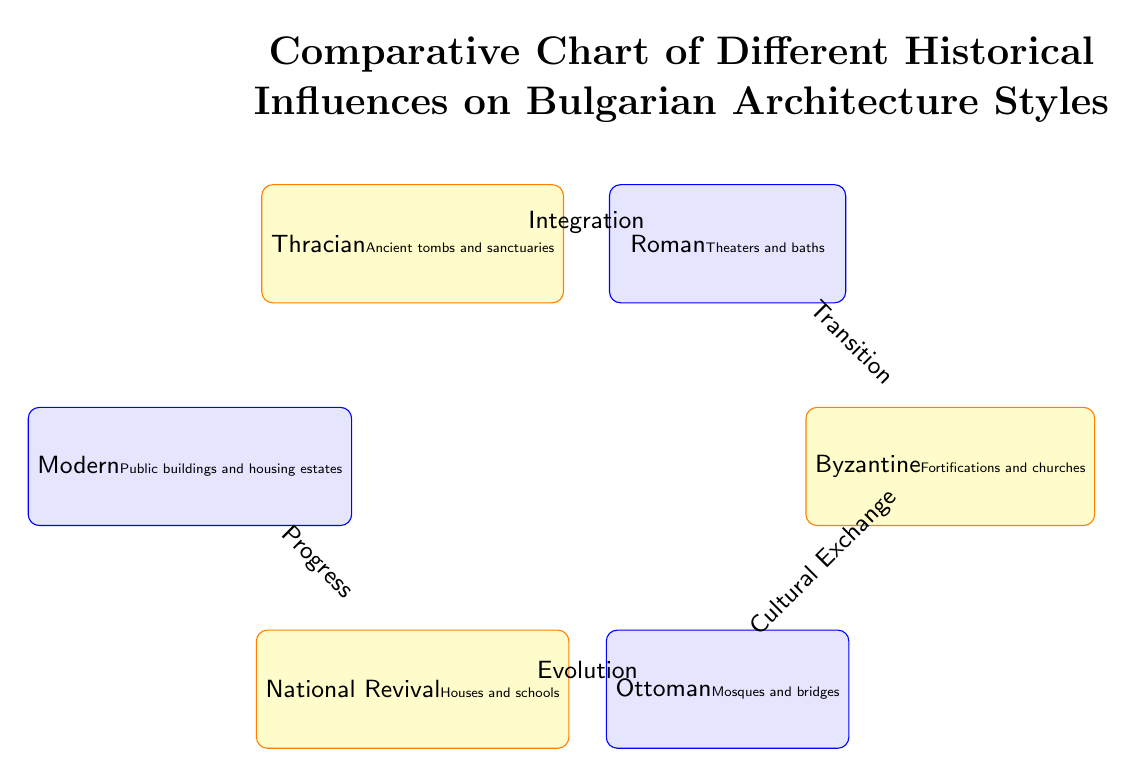What is the first historical influence depicted in the chart? The first node in the diagram is labeled "Thracian," indicating it is the first historical influence presented.
Answer: Thracian Which architecture style is associated with mosques and bridges? The node that contains "Mosques and bridges" is labeled as "Ottoman," indicating this architecture style is associated with that description.
Answer: Ottoman What relationship connects the Thracian and Roman influences? The diagram illustrates an arrow labeled "Integration" connecting the "Thracian" node and the "Roman" node, indicating the nature of the relationship between these two influences.
Answer: Integration Which style follows the Byzantine influence in the chart? Following the "Byzantine" node, the next node down in the chart is "Ottoman," indicating it is the style that comes after Byzantine.
Answer: Ottoman How many total architecture styles are represented in the chart? By counting the nodes in the diagram, there are six distinct styles displayed, which include Thracian, Roman, Byzantine, Ottoman, National Revival, and Modern.
Answer: 6 What type of building is associated with the National Revival style? The National Revival node explicitly mentions "Houses and schools," indicating these types of buildings are aligned with this architectural style.
Answer: Houses and schools What is the flow direction from the Modern style to previous styles? The arrow from "Modern" style points upwards back to "National Revival," indicating a progression from Modern architecture to the earlier styles presented in the chart.
Answer: Progress Which two styles are connected by the term "Cultural Exchange"? The "Cultural Exchange" relationship directly connects the "Byzantine" style to the "Ottoman" style, indicating this specific interaction.
Answer: Byzantine and Ottoman Which architecture style is placed at the top of the chart? The chart does not have any nodes above; however, "Modern" is the highest style in this visual representation based on the directed arrows indicating progressions.
Answer: Modern 